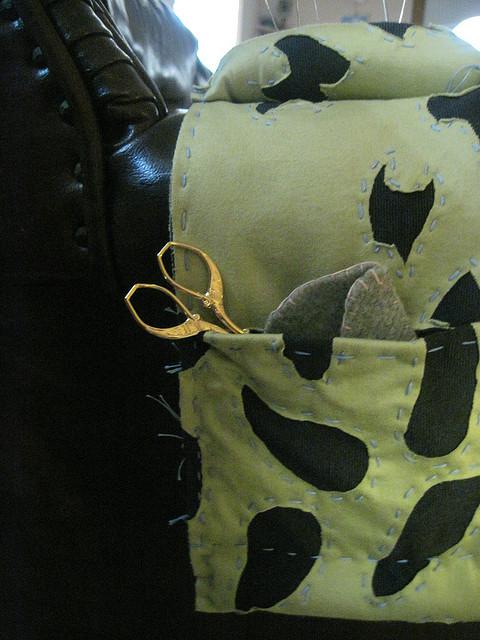What color are the patches on the couch?
Concise answer only. Black. What is the patches made of?
Short answer required. Fabric. What color is the couch?
Be succinct. Black. 